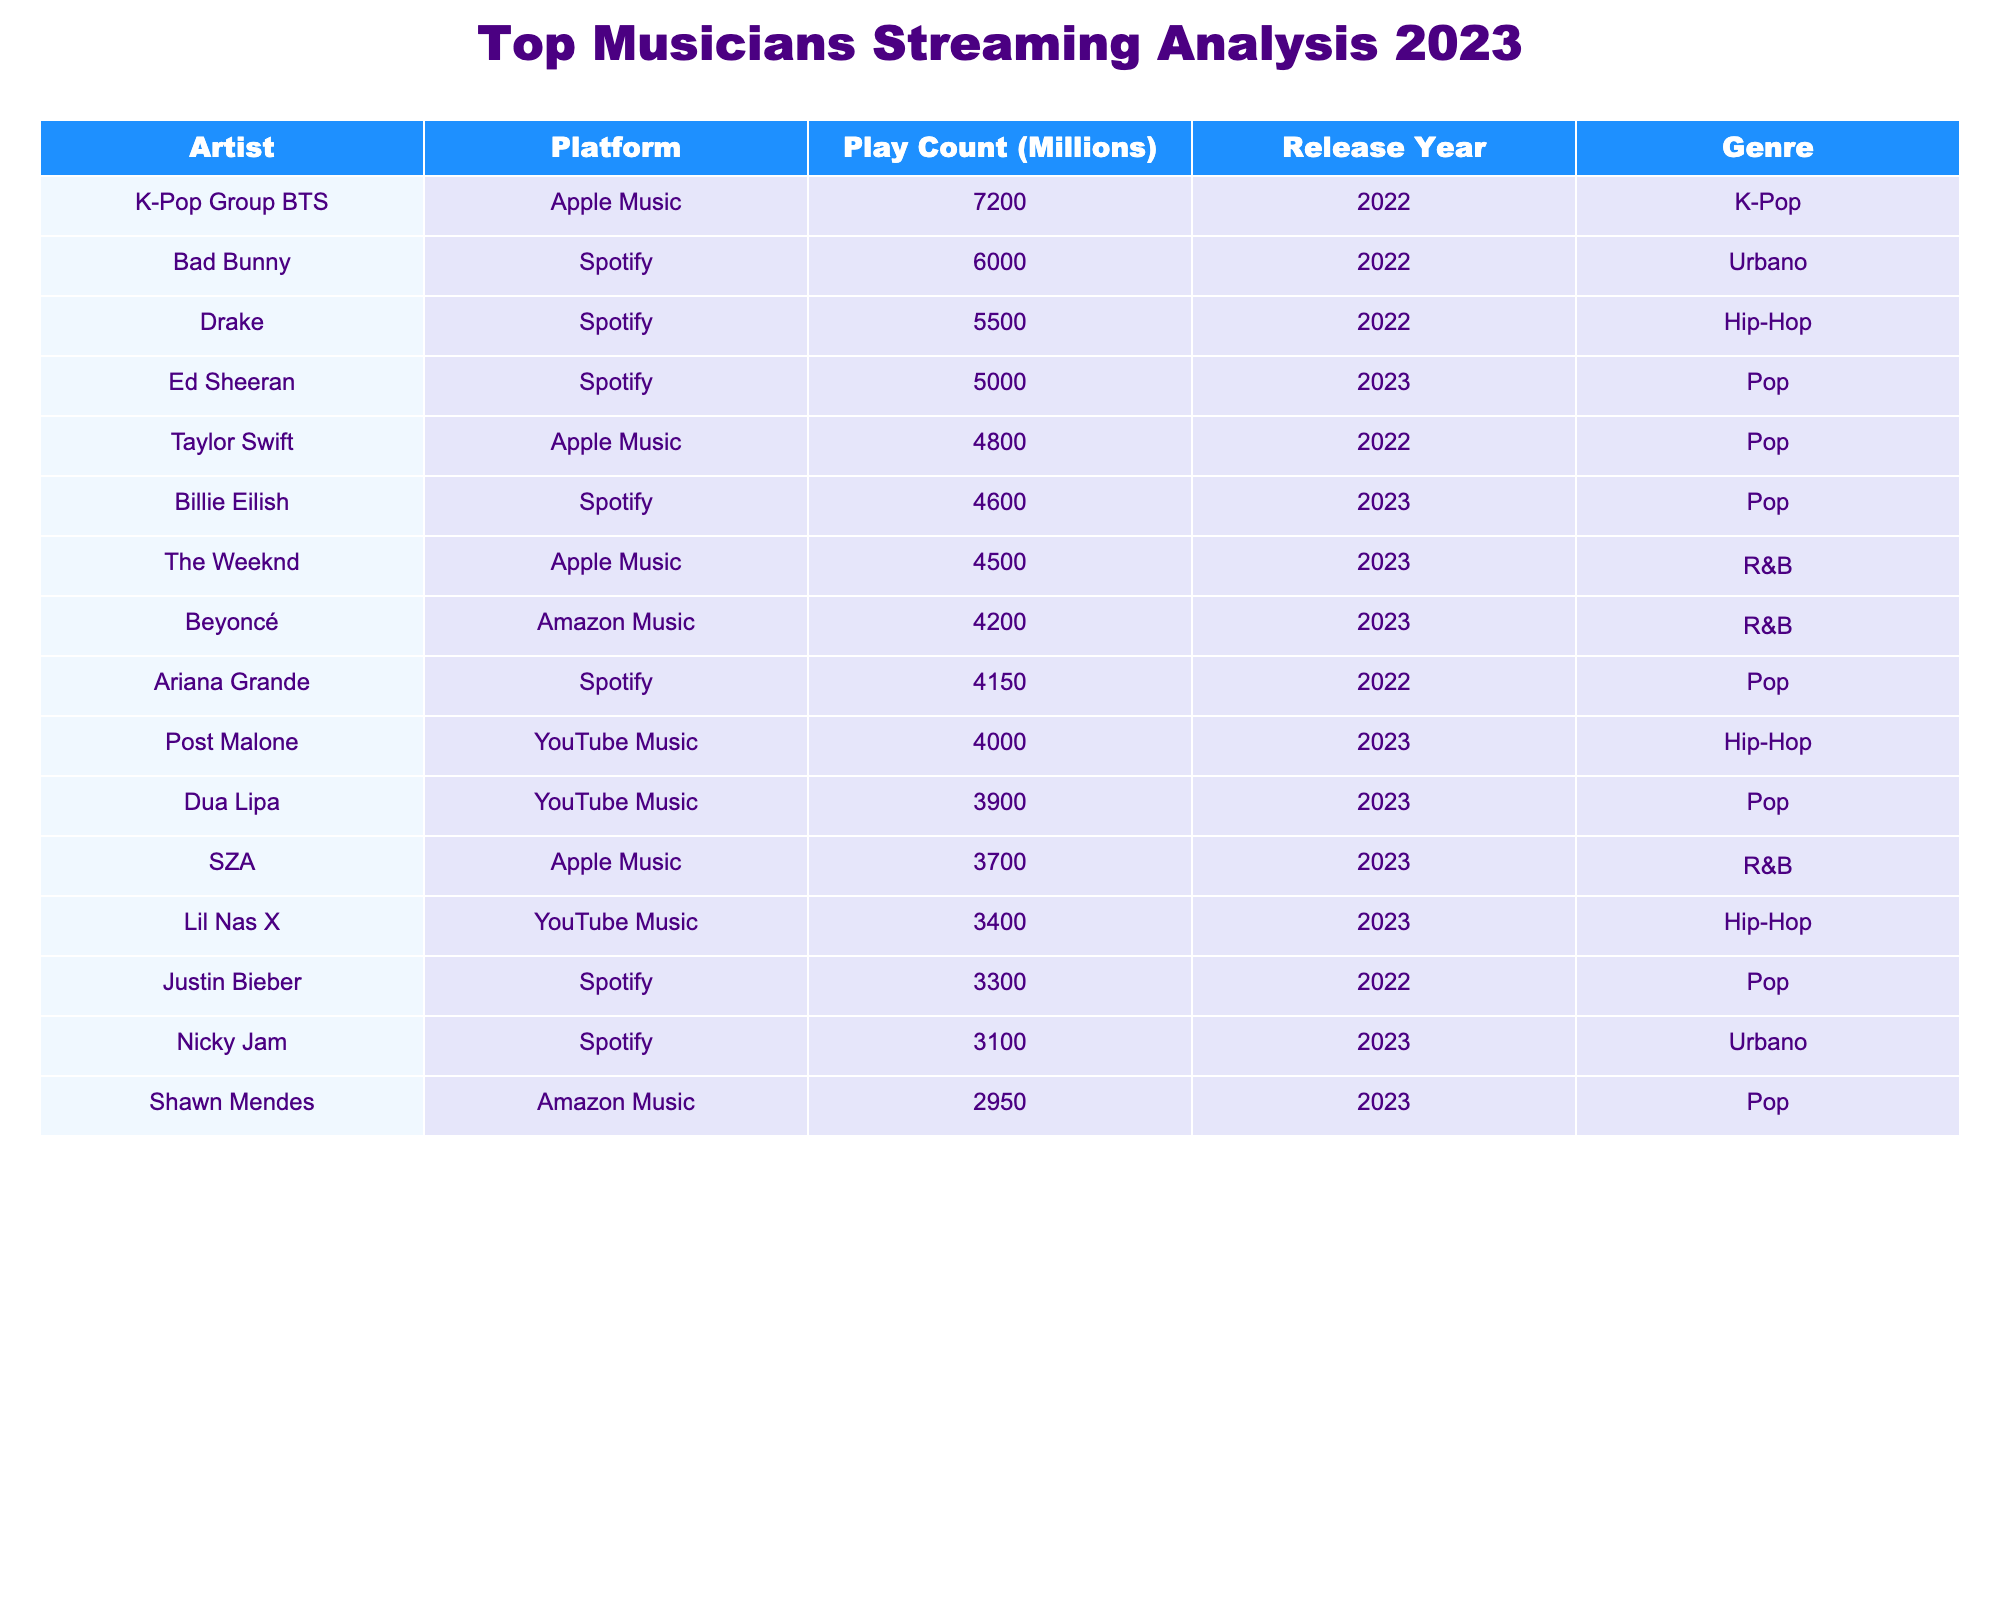What is the artist with the highest play count on Spotify in 2023? The highest play count in 2023 is attributed to Bad Bunny on Spotify with 6000 million plays.
Answer: Bad Bunny What is the total play count for all artists on Apple Music in 2023? The artists on Apple Music in 2023 are The Weeknd (4500), Beyoncé (4200), and SZA (3700). Adding these gives 4500 + 4200 + 3700 = 12400 million plays.
Answer: 12400 million Did Drake release music in 2023? The data shows Drake released music in 2022, so he did not have new music in 2023 according to this table.
Answer: No Which genre had the highest total play count across all platforms in 2023? Collecting the data for 2023: R&B (4500 + 4200 + 3700 = 12400), Pop (5000 + 3900 + 4600 + 2950 = 16850), Urbano (3100), and Hip-Hop (4000 + 3400 = 7400). Pop has the highest total with 16850 million plays.
Answer: Pop What is the average play count of artists on YouTube Music in 2023? The YouTube Music play counts for 2023 are Dua Lipa (3900), Post Malone (4000), and Lil Nas X (3400). To find the average, sum these (3900 + 4000 + 3400 = 11300) and divide by the number of artists (3). So, 11300 / 3 = 3766.67 million.
Answer: 3766.67 million What percentage of Taylor Swift's play count does Ed Sheeran's play count represent from their respective platforms? Taylor Swift's count is 4800 million (Apple Music) and Ed Sheeran's count is 5000 million (Spotify). To find the percentage, divide Ed Sheeran's count by Taylor Swift's and multiply by 100: (5000 / 4800) * 100 = 104.17%.
Answer: 104.17% Are there any artists in the table who have both released music in 2022 and have a play count in 2023? In the provided data, Bad Bunny, Taylor Swift, Drake, K-Pop Group BTS, and Justin Bieber released music in 2022, but none of these artists have play counts for 2023 listed in the table so the answer is no.
Answer: No What is the difference in play counts between the top artist on Spotify and the top artist on Apple Music in 2023? The top artist on Spotify in 2023 is Ed Sheeran with 5000 million and the top artist on Apple Music is The Weeknd with 4500 million. Subtracting gives 5000 - 4500 = 500 million.
Answer: 500 million 